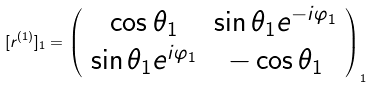Convert formula to latex. <formula><loc_0><loc_0><loc_500><loc_500>[ r ^ { ( 1 ) } ] _ { 1 } = \left ( \begin{array} { c c } \cos \theta _ { 1 } & \sin \theta _ { 1 } e ^ { - i \varphi _ { 1 } } \\ \sin \theta _ { 1 } e ^ { i \varphi _ { 1 } } & - \cos \theta _ { 1 } \end{array} \right ) _ { 1 }</formula> 